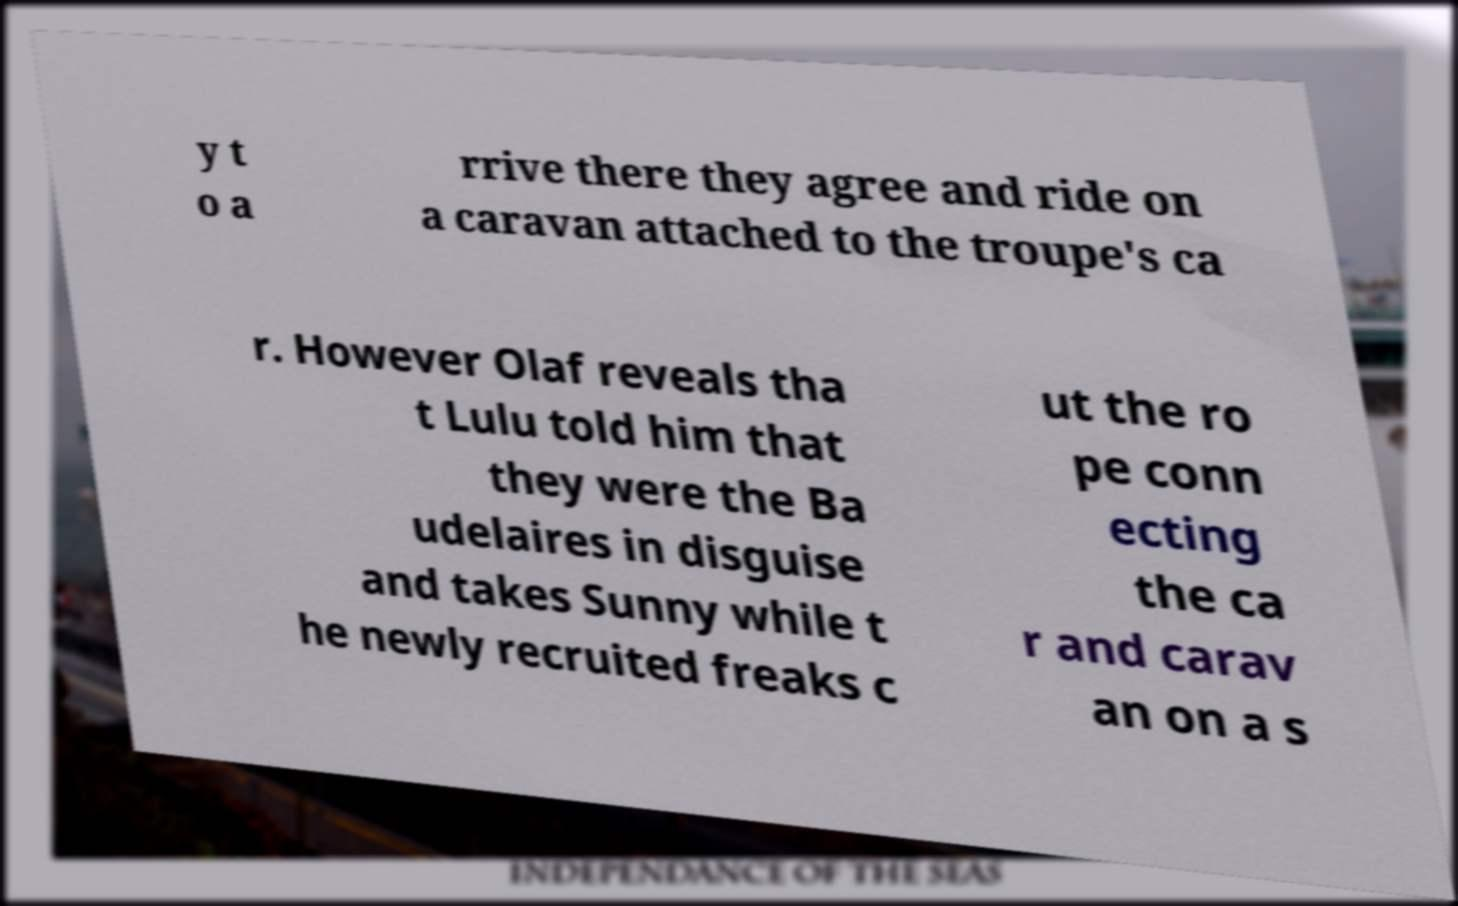Can you accurately transcribe the text from the provided image for me? y t o a rrive there they agree and ride on a caravan attached to the troupe's ca r. However Olaf reveals tha t Lulu told him that they were the Ba udelaires in disguise and takes Sunny while t he newly recruited freaks c ut the ro pe conn ecting the ca r and carav an on a s 